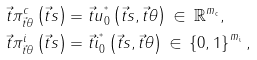Convert formula to latex. <formula><loc_0><loc_0><loc_500><loc_500>\vec { t } { \pi } ^ { c } _ { \vec { t } \theta } \left ( \vec { t } s \right ) & = \vec { t } u _ { 0 } ^ { ^ { * } } \left ( \vec { t } { s } , \vec { t } { \theta } \right ) \, \in \, \mathbb { R } ^ { m _ { \mathrm c } } , \\ \vec { t } { \pi } ^ { i } _ { \vec { t } \theta } \left ( \vec { t } s \right ) & = \vec { t } i _ { 0 } ^ { ^ { * } } \left ( \vec { t } { s } , \vec { t } { \theta } \right ) \, \in \, \left \{ 0 , 1 \right \} ^ { m _ { \mathrm i } } ,</formula> 